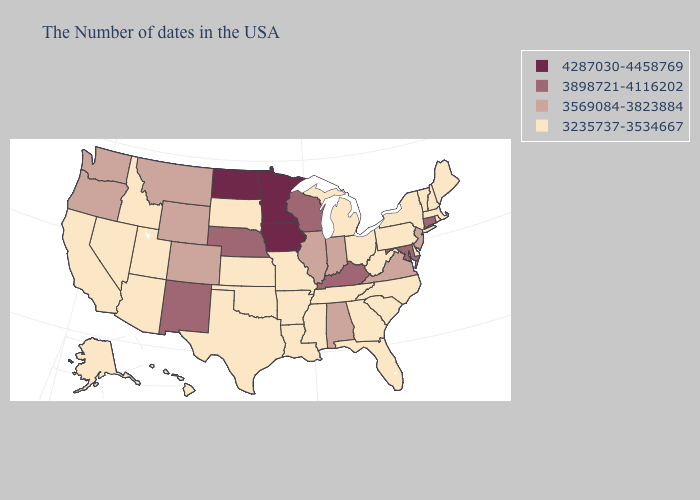Is the legend a continuous bar?
Answer briefly. No. Name the states that have a value in the range 3569084-3823884?
Give a very brief answer. New Jersey, Virginia, Indiana, Alabama, Illinois, Wyoming, Colorado, Montana, Washington, Oregon. Does Connecticut have the highest value in the Northeast?
Concise answer only. Yes. What is the value of Tennessee?
Quick response, please. 3235737-3534667. What is the value of California?
Answer briefly. 3235737-3534667. Does Nebraska have the highest value in the MidWest?
Give a very brief answer. No. Does Connecticut have the highest value in the Northeast?
Concise answer only. Yes. Name the states that have a value in the range 3898721-4116202?
Write a very short answer. Connecticut, Maryland, Kentucky, Wisconsin, Nebraska, New Mexico. Does West Virginia have the same value as Wisconsin?
Short answer required. No. What is the value of West Virginia?
Give a very brief answer. 3235737-3534667. What is the highest value in states that border Indiana?
Concise answer only. 3898721-4116202. Which states hav the highest value in the West?
Quick response, please. New Mexico. Which states have the highest value in the USA?
Short answer required. Minnesota, Iowa, North Dakota. Among the states that border Mississippi , which have the lowest value?
Short answer required. Tennessee, Louisiana, Arkansas. Does Michigan have the highest value in the USA?
Short answer required. No. 